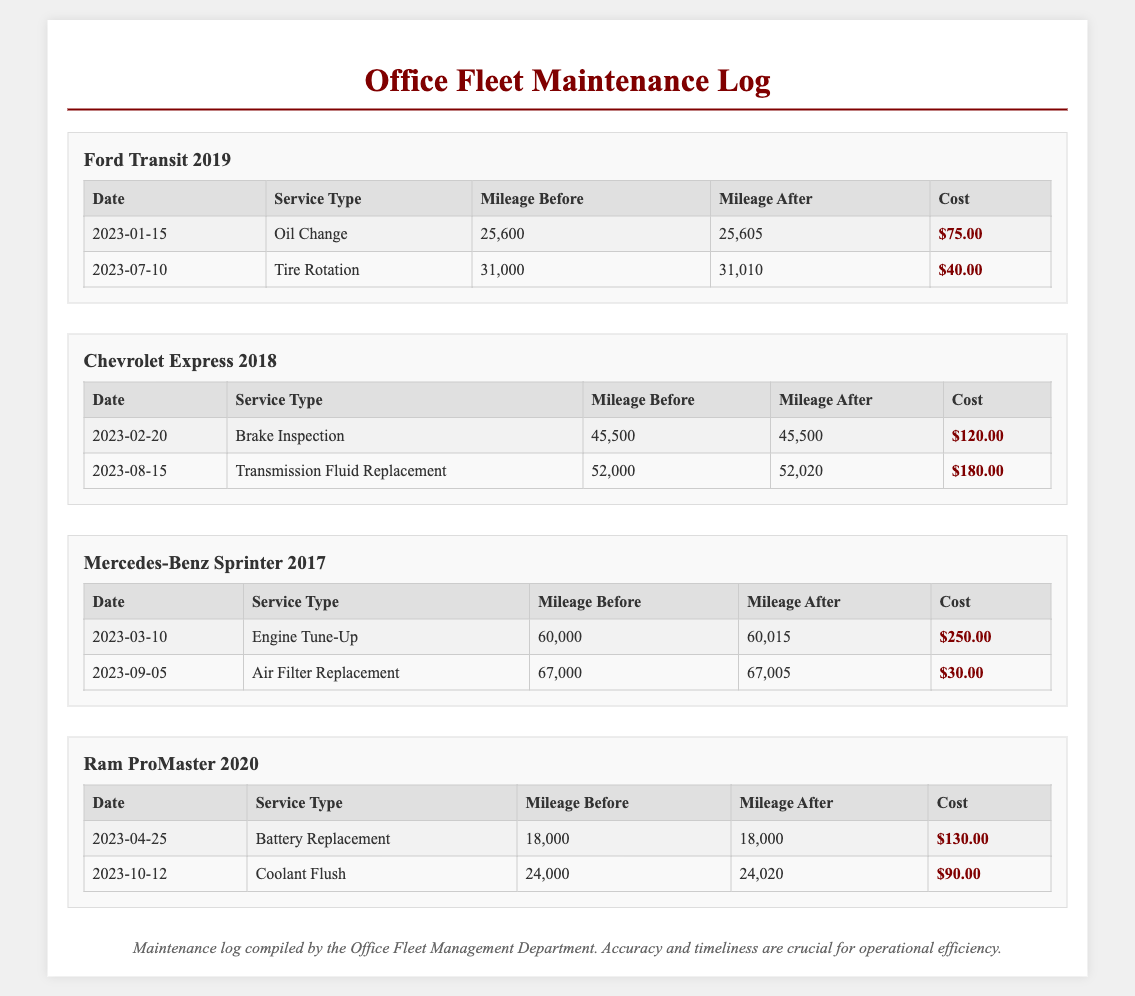What is the service type for the 2023-01-15 entry for Ford Transit? The service type listed for the Ford Transit on this date is an "Oil Change."
Answer: Oil Change What is the mileage before service for the Chevrolet Express on 2023-02-20? The mileage before service for the Chevrolet Express on this date is 45,500.
Answer: 45,500 What was the cost of the engine tune-up for the Mercedes-Benz Sprinter? The cost of the engine tune-up conducted was $250.00 on 2023-03-10.
Answer: $250.00 How many miles did the Ram ProMaster travel after its coolant flush? The mileage after the coolant flush is 24,020, which indicates it traveled 20 miles after the service.
Answer: 20 What is the total cost of services performed on the Ford Transit? The total cost is calculated by adding all service costs for the Ford Transit: $75.00 + $40.00 = $115.00.
Answer: $115.00 Which vehicle had a brake inspection performed, and when? The Chevrolet Express had a brake inspection on 2023-02-20.
Answer: Chevrolet Express, 2023-02-20 What type of service was performed on the Chevrolet Express on 2023-08-15? The service performed was "Transmission Fluid Replacement."
Answer: Transmission Fluid Replacement How many total services were performed on the Ram ProMaster? A total of two services were performed on the Ram ProMaster, as listed in the log.
Answer: Two What is the mileage after the tire rotation for the Ford Transit? The mileage after the tire rotation for the Ford Transit is 31,010.
Answer: 31,010 